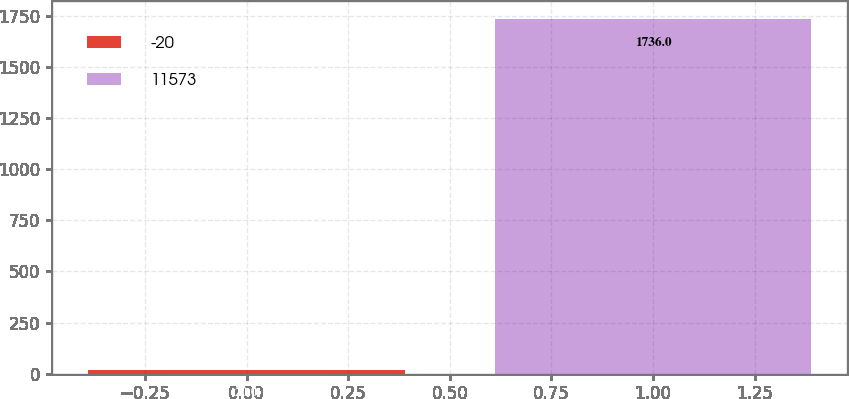<chart> <loc_0><loc_0><loc_500><loc_500><bar_chart><fcel>-20<fcel>11573<nl><fcel>20<fcel>1736<nl></chart> 